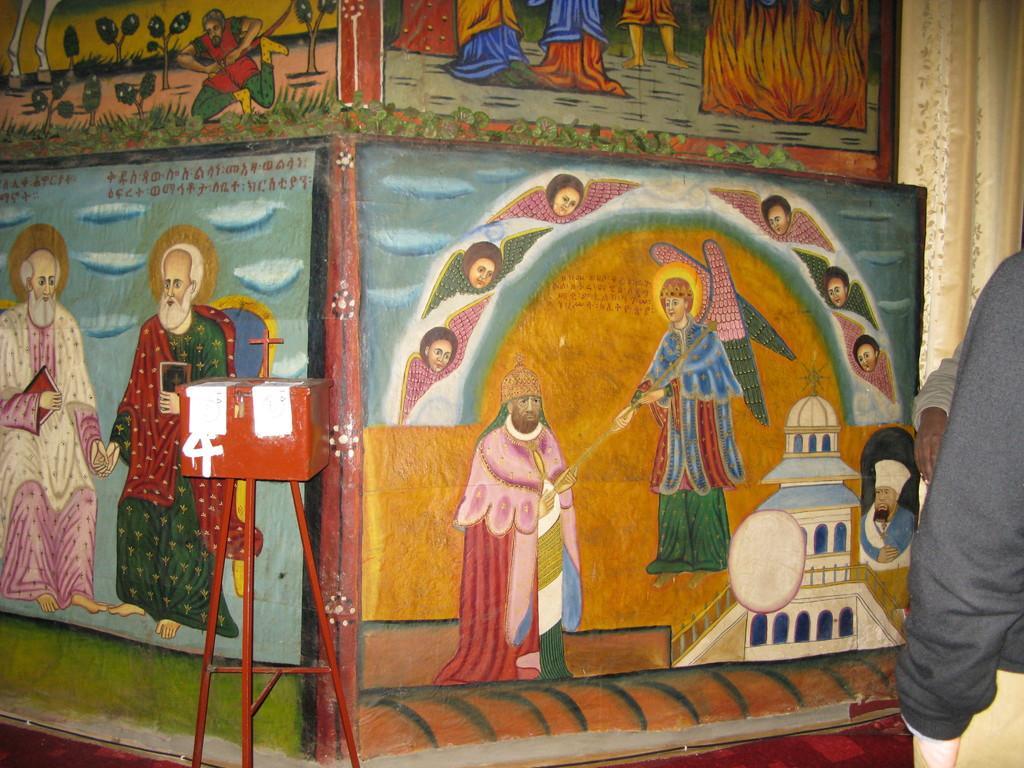Can you describe this image briefly? In this picture I can see painting of humans on the wall and I can see couple of humans standing on the right side and I can see a metal box on the stand. 